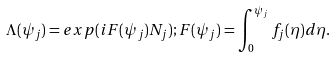<formula> <loc_0><loc_0><loc_500><loc_500>\Lambda ( \psi _ { j } ) = e x p ( i F ( \psi _ { j } ) N _ { j } ) ; F ( \psi _ { j } ) = \int _ { 0 } ^ { \psi _ { j } } f _ { j } ( \eta ) d \eta .</formula> 